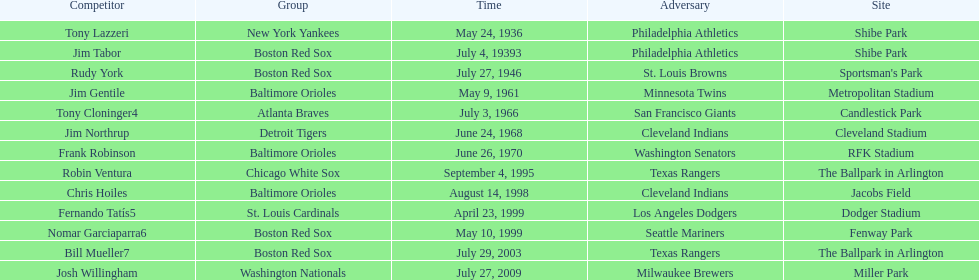Who was the opponent for the boston red sox on july 27, 1946? St. Louis Browns. 